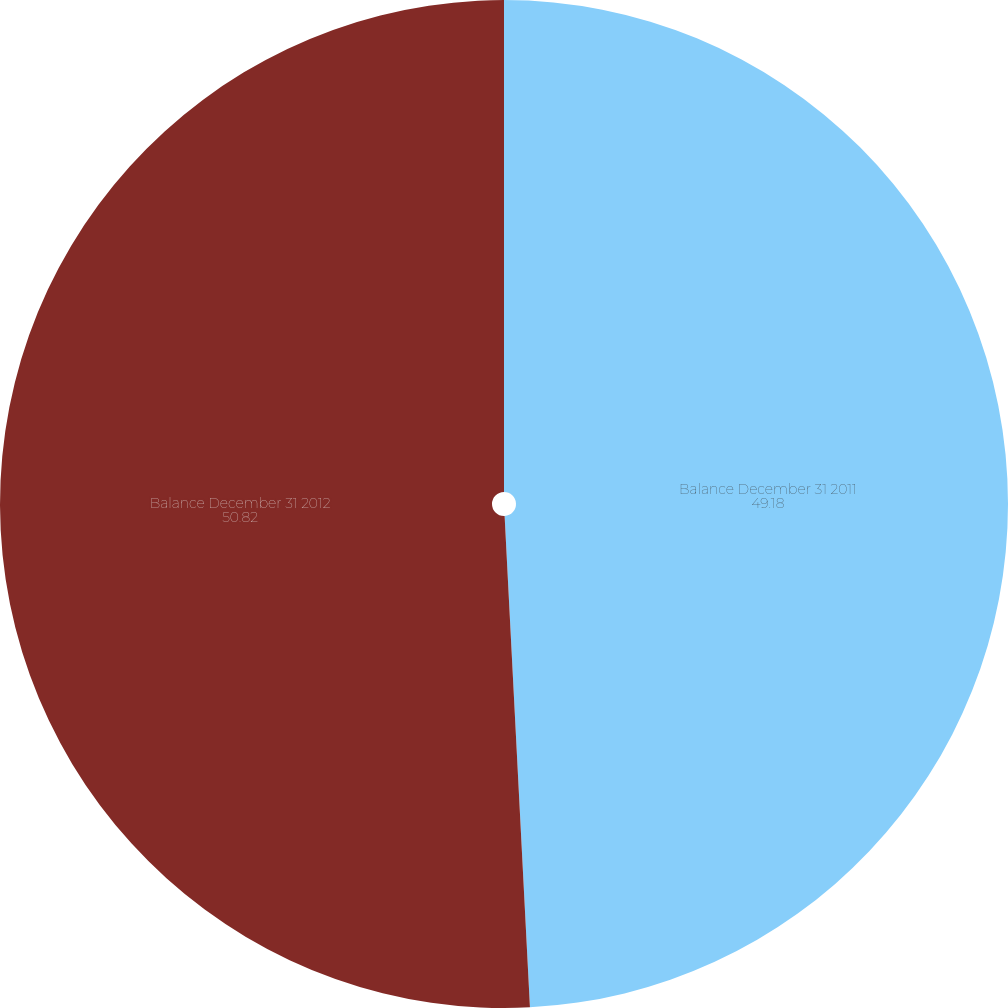<chart> <loc_0><loc_0><loc_500><loc_500><pie_chart><fcel>Balance December 31 2011<fcel>Balance December 31 2012<nl><fcel>49.18%<fcel>50.82%<nl></chart> 